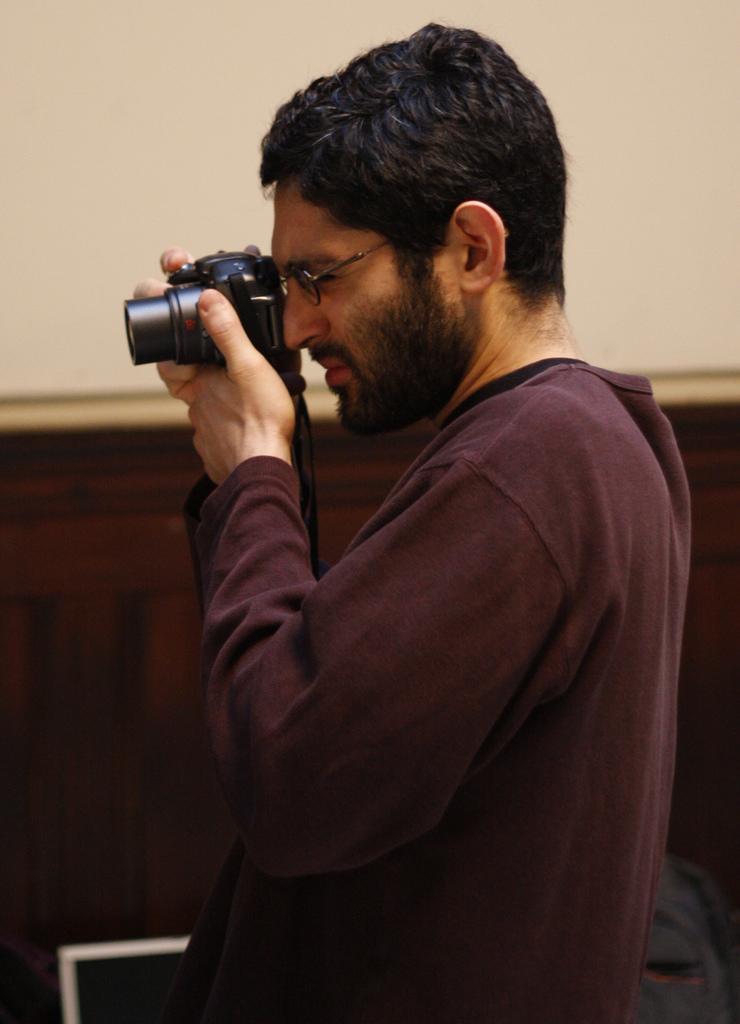Describe this image in one or two sentences. In this image there is a man standing and holding a camera, there is an object towards the right of the image, there is an object towards the bottom of the image, there is a curtain, there is a wall towards the top of the image. 